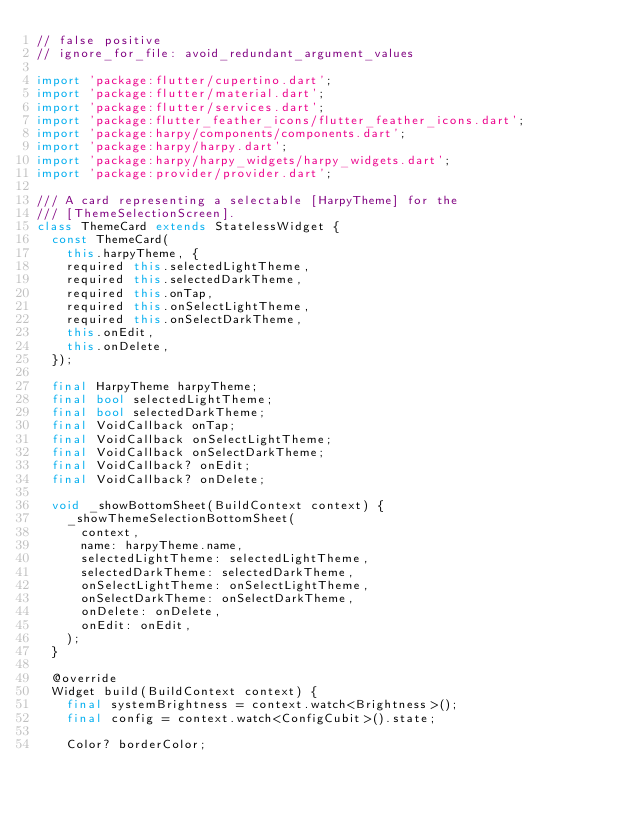Convert code to text. <code><loc_0><loc_0><loc_500><loc_500><_Dart_>// false positive
// ignore_for_file: avoid_redundant_argument_values

import 'package:flutter/cupertino.dart';
import 'package:flutter/material.dart';
import 'package:flutter/services.dart';
import 'package:flutter_feather_icons/flutter_feather_icons.dart';
import 'package:harpy/components/components.dart';
import 'package:harpy/harpy.dart';
import 'package:harpy/harpy_widgets/harpy_widgets.dart';
import 'package:provider/provider.dart';

/// A card representing a selectable [HarpyTheme] for the
/// [ThemeSelectionScreen].
class ThemeCard extends StatelessWidget {
  const ThemeCard(
    this.harpyTheme, {
    required this.selectedLightTheme,
    required this.selectedDarkTheme,
    required this.onTap,
    required this.onSelectLightTheme,
    required this.onSelectDarkTheme,
    this.onEdit,
    this.onDelete,
  });

  final HarpyTheme harpyTheme;
  final bool selectedLightTheme;
  final bool selectedDarkTheme;
  final VoidCallback onTap;
  final VoidCallback onSelectLightTheme;
  final VoidCallback onSelectDarkTheme;
  final VoidCallback? onEdit;
  final VoidCallback? onDelete;

  void _showBottomSheet(BuildContext context) {
    _showThemeSelectionBottomSheet(
      context,
      name: harpyTheme.name,
      selectedLightTheme: selectedLightTheme,
      selectedDarkTheme: selectedDarkTheme,
      onSelectLightTheme: onSelectLightTheme,
      onSelectDarkTheme: onSelectDarkTheme,
      onDelete: onDelete,
      onEdit: onEdit,
    );
  }

  @override
  Widget build(BuildContext context) {
    final systemBrightness = context.watch<Brightness>();
    final config = context.watch<ConfigCubit>().state;

    Color? borderColor;
</code> 